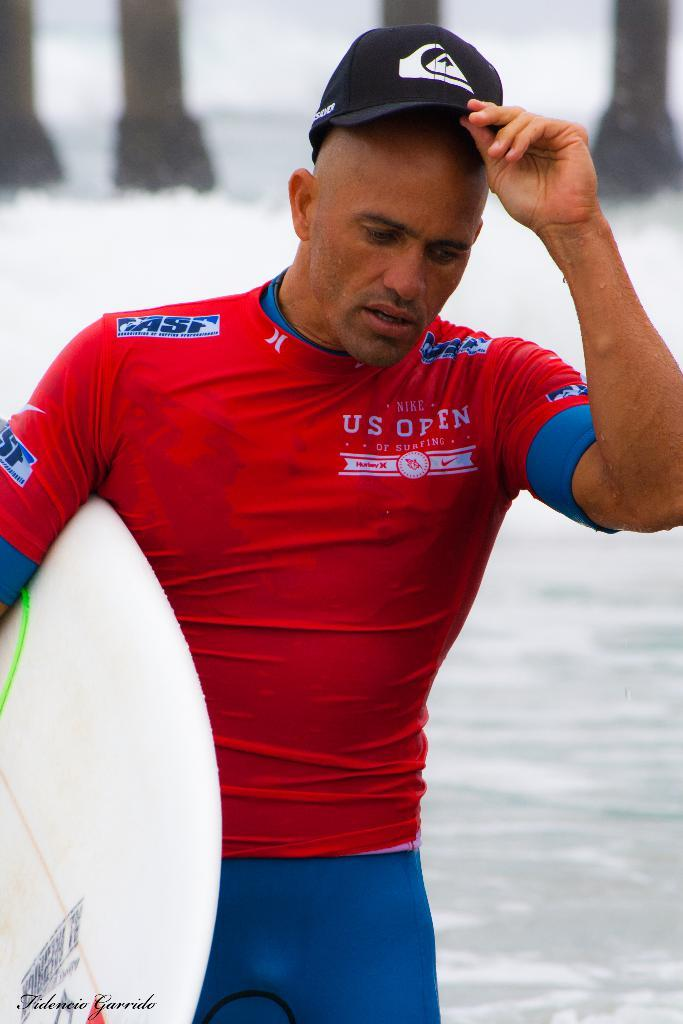Provide a one-sentence caption for the provided image. A man wears a red shirt for "Nike US Open of Surfing.". 